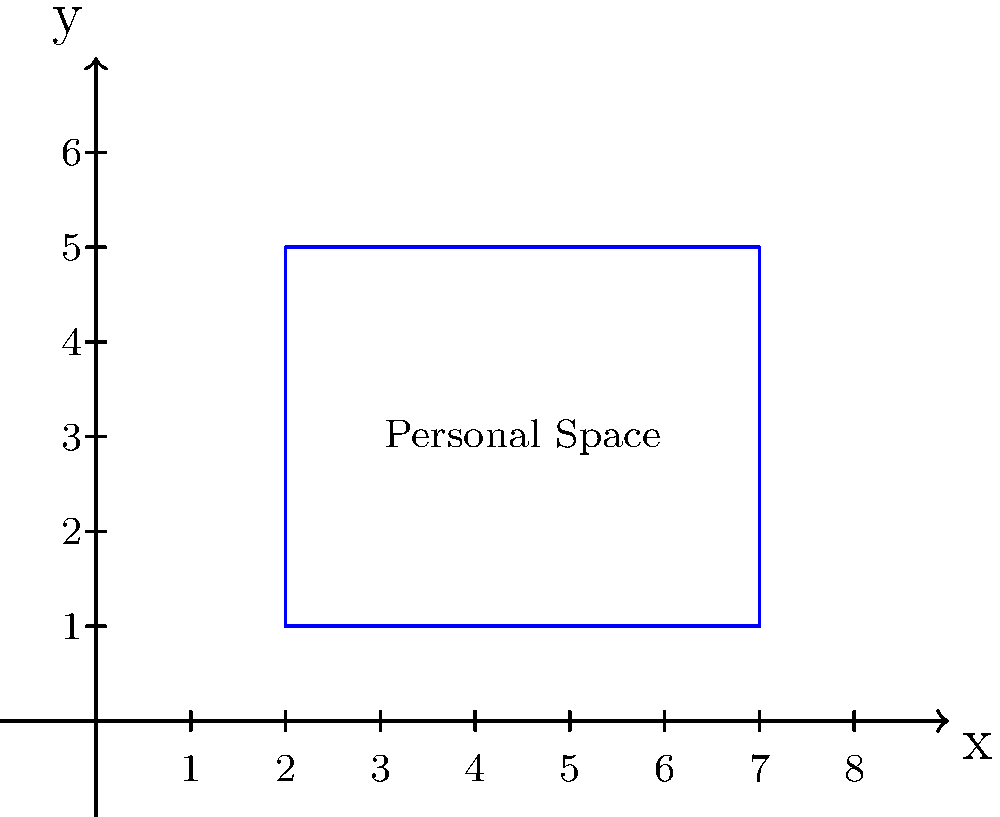In the coordinate plane above, a rectangle represents an actor's personal space in relation to public exposure. The rectangle has vertices at (2,1), (7,1), (7,5), and (2,5). Calculate the area of this rectangle, which symbolizes the balance between the actor's private life and public presence. To find the area of the rectangle, we need to calculate its length and width, then multiply them:

1. Find the width (along the x-axis):
   $x_2 - x_1 = 7 - 2 = 5$ units

2. Find the height (along the y-axis):
   $y_2 - y_1 = 5 - 1 = 4$ units

3. Calculate the area using the formula:
   $A = \text{width} \times \text{height}$
   $A = 5 \times 4 = 20$ square units

Therefore, the area of the rectangle representing the actor's personal space vs. public exposure is 20 square units.
Answer: 20 square units 